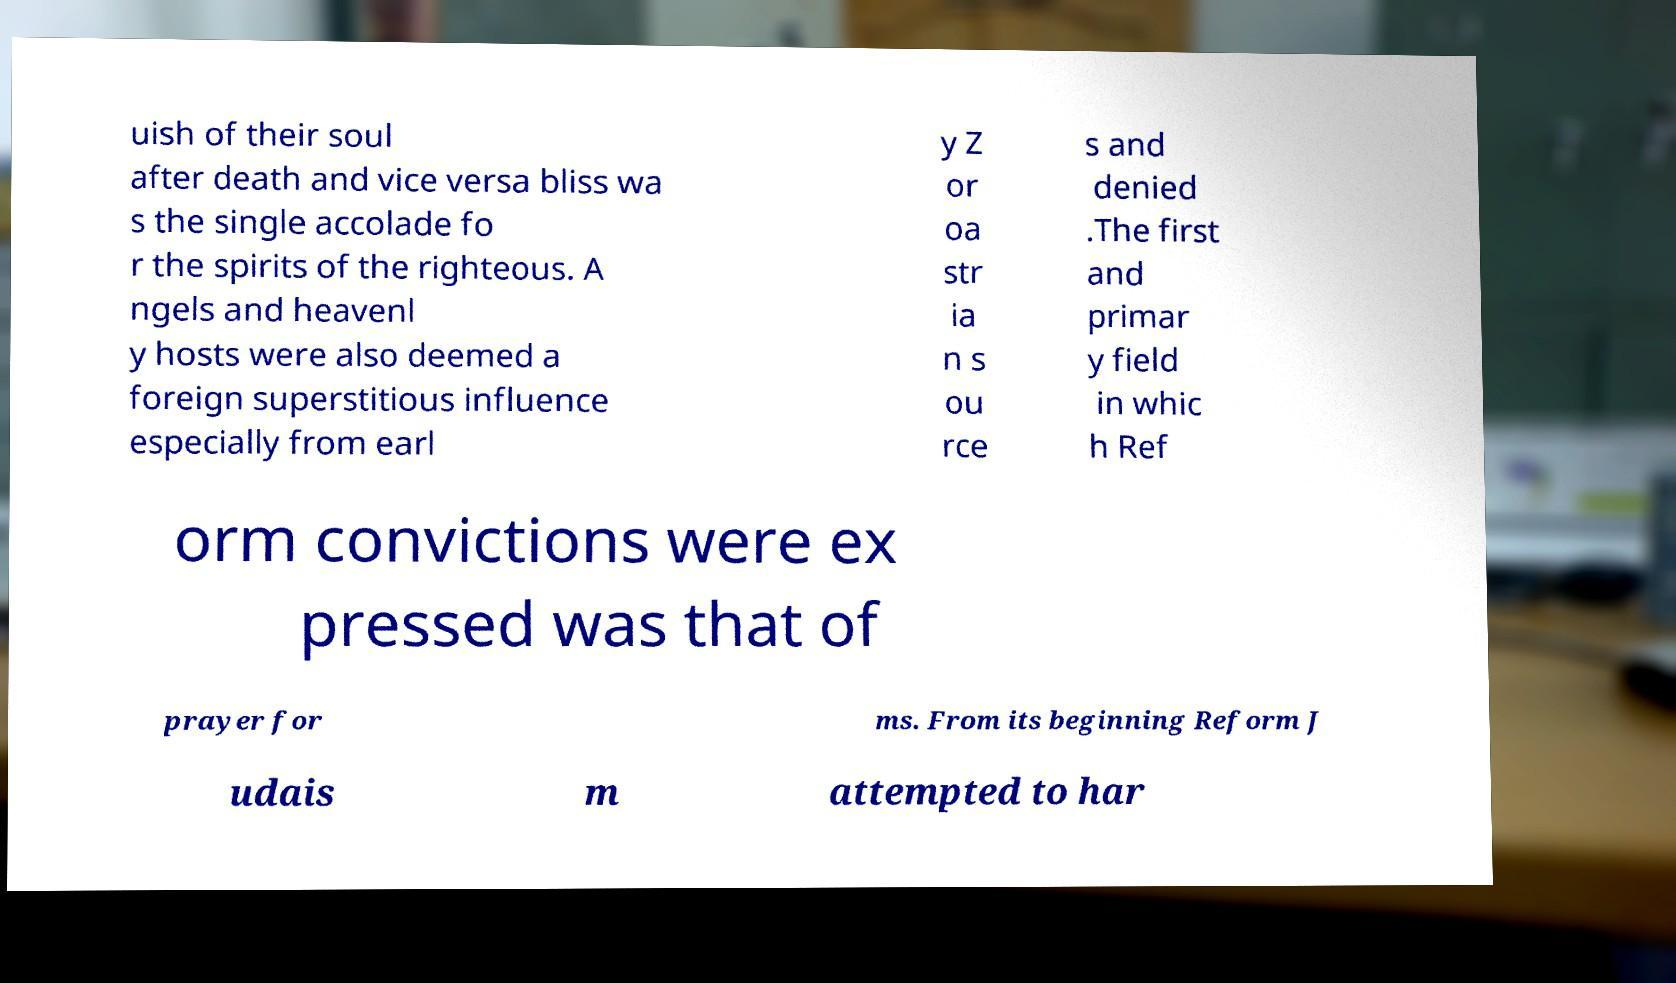Can you read and provide the text displayed in the image?This photo seems to have some interesting text. Can you extract and type it out for me? uish of their soul after death and vice versa bliss wa s the single accolade fo r the spirits of the righteous. A ngels and heavenl y hosts were also deemed a foreign superstitious influence especially from earl y Z or oa str ia n s ou rce s and denied .The first and primar y field in whic h Ref orm convictions were ex pressed was that of prayer for ms. From its beginning Reform J udais m attempted to har 